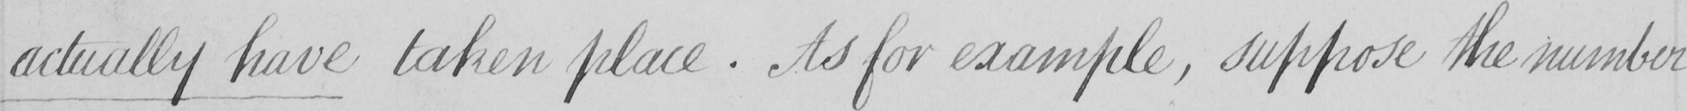Can you read and transcribe this handwriting? actually have taken place . As for example , suppose the number 